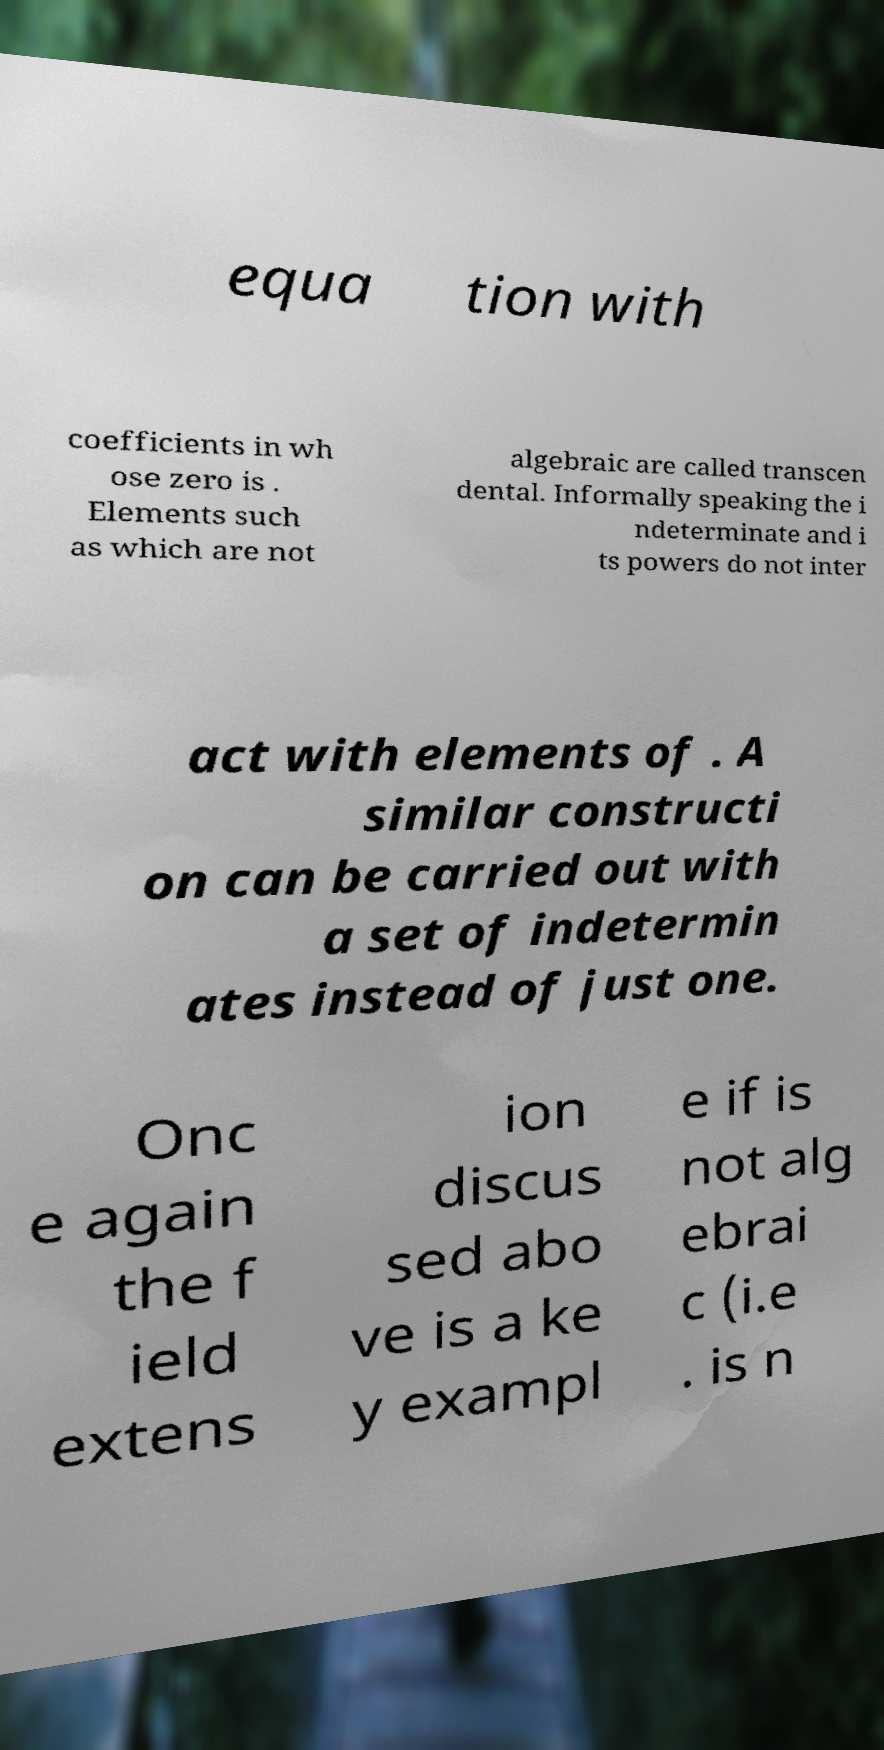Please read and relay the text visible in this image. What does it say? equa tion with coefficients in wh ose zero is . Elements such as which are not algebraic are called transcen dental. Informally speaking the i ndeterminate and i ts powers do not inter act with elements of . A similar constructi on can be carried out with a set of indetermin ates instead of just one. Onc e again the f ield extens ion discus sed abo ve is a ke y exampl e if is not alg ebrai c (i.e . is n 